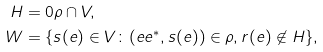Convert formula to latex. <formula><loc_0><loc_0><loc_500><loc_500>H & = 0 \rho \cap V , \\ W & = \{ s ( e ) \in V \colon ( e e ^ { \ast } , s ( e ) ) \in \rho , r ( e ) \not \in H \} ,</formula> 